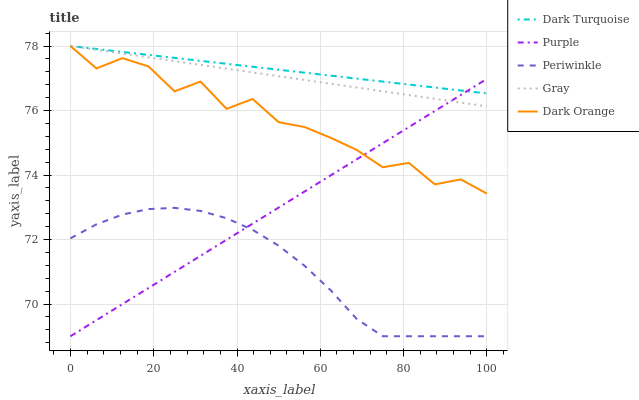Does Periwinkle have the minimum area under the curve?
Answer yes or no. Yes. Does Dark Turquoise have the maximum area under the curve?
Answer yes or no. Yes. Does Dark Turquoise have the minimum area under the curve?
Answer yes or no. No. Does Periwinkle have the maximum area under the curve?
Answer yes or no. No. Is Purple the smoothest?
Answer yes or no. Yes. Is Dark Orange the roughest?
Answer yes or no. Yes. Is Dark Turquoise the smoothest?
Answer yes or no. No. Is Dark Turquoise the roughest?
Answer yes or no. No. Does Dark Turquoise have the lowest value?
Answer yes or no. No. Does Gray have the highest value?
Answer yes or no. Yes. Does Periwinkle have the highest value?
Answer yes or no. No. Is Periwinkle less than Dark Turquoise?
Answer yes or no. Yes. Is Dark Orange greater than Periwinkle?
Answer yes or no. Yes. Does Dark Turquoise intersect Purple?
Answer yes or no. Yes. Is Dark Turquoise less than Purple?
Answer yes or no. No. Is Dark Turquoise greater than Purple?
Answer yes or no. No. Does Periwinkle intersect Dark Turquoise?
Answer yes or no. No. 